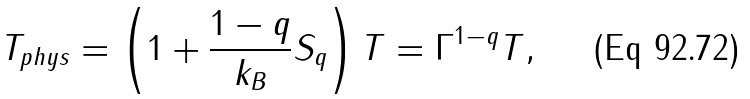Convert formula to latex. <formula><loc_0><loc_0><loc_500><loc_500>T _ { p h y s } = \left ( 1 + \frac { 1 - q } { k _ { B } } S _ { q } \right ) T = \Gamma ^ { 1 - q } T ,</formula> 